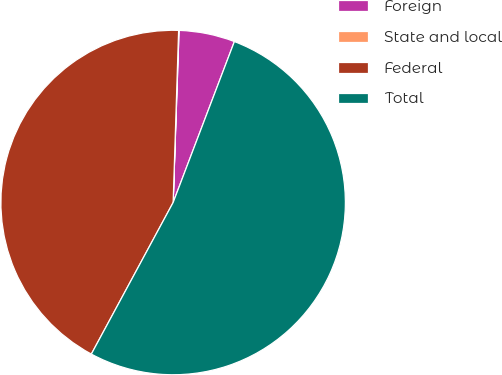Convert chart. <chart><loc_0><loc_0><loc_500><loc_500><pie_chart><fcel>Foreign<fcel>State and local<fcel>Federal<fcel>Total<nl><fcel>5.24%<fcel>0.04%<fcel>42.63%<fcel>52.09%<nl></chart> 